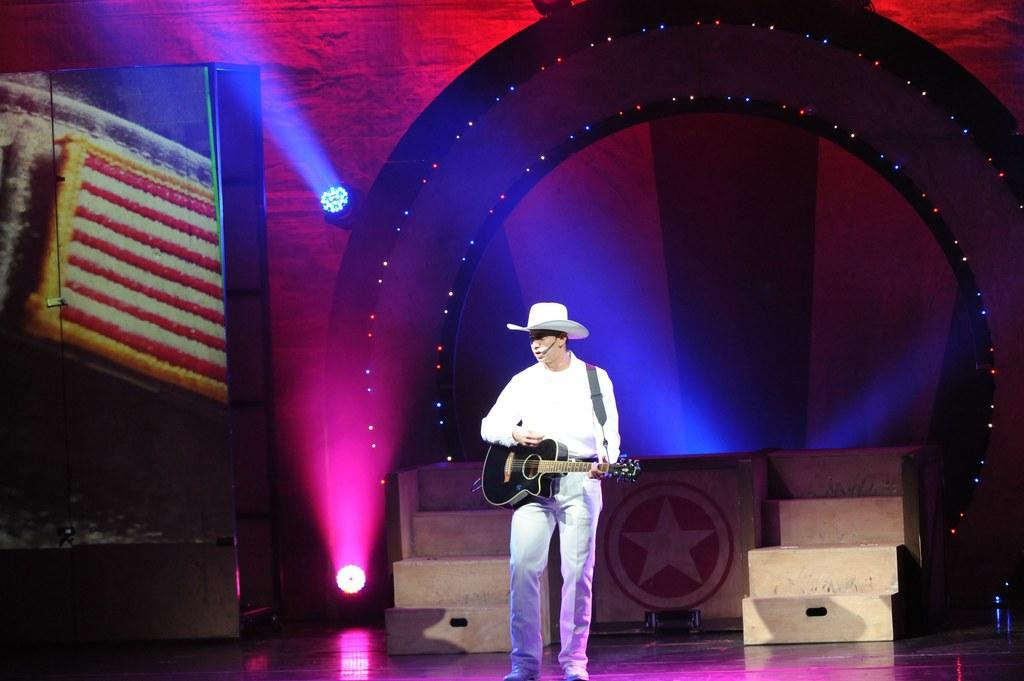What is the main setting of the image? The image appears to be a stage. What is the man on the stage doing? The man is playing the guitar. What is the man wearing on his upper body? The man is wearing a white shirt. What type of headwear is the man wearing? The man is wearing a cap on his head. What can be seen in the background of the stage? There are lights in the background of the stage. Can you see a knife being used by the man on the stage? There is no knife visible in the image, and the man is not using one. Is there a volcano erupting in the background of the stage? There is no volcano present in the image; the background features lights. 